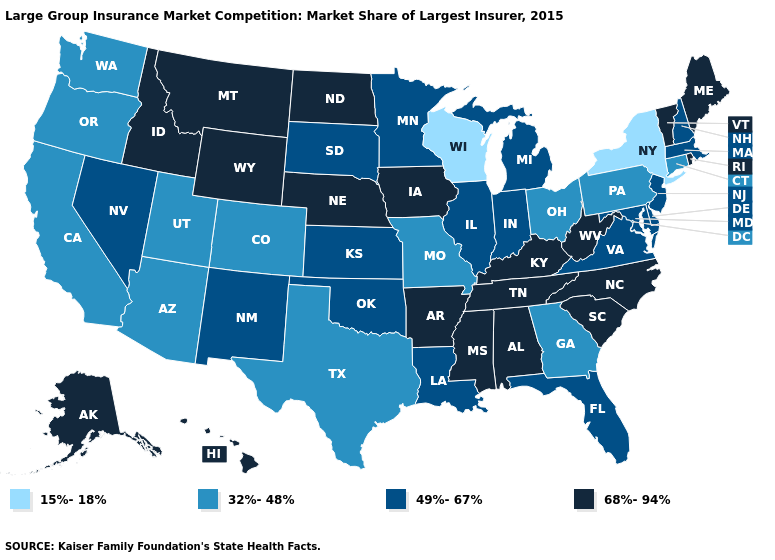What is the value of Kentucky?
Give a very brief answer. 68%-94%. How many symbols are there in the legend?
Give a very brief answer. 4. Among the states that border Kansas , does Oklahoma have the lowest value?
Write a very short answer. No. What is the value of New Hampshire?
Quick response, please. 49%-67%. Which states have the lowest value in the USA?
Concise answer only. New York, Wisconsin. What is the lowest value in the West?
Be succinct. 32%-48%. What is the value of New Mexico?
Give a very brief answer. 49%-67%. Name the states that have a value in the range 32%-48%?
Write a very short answer. Arizona, California, Colorado, Connecticut, Georgia, Missouri, Ohio, Oregon, Pennsylvania, Texas, Utah, Washington. Does Montana have the lowest value in the USA?
Answer briefly. No. Among the states that border South Carolina , which have the highest value?
Quick response, please. North Carolina. Does Delaware have the same value as Utah?
Quick response, please. No. Does Montana have the highest value in the West?
Short answer required. Yes. Does Utah have the highest value in the West?
Short answer required. No. Does Utah have a lower value than Wisconsin?
Quick response, please. No. What is the value of Indiana?
Concise answer only. 49%-67%. 